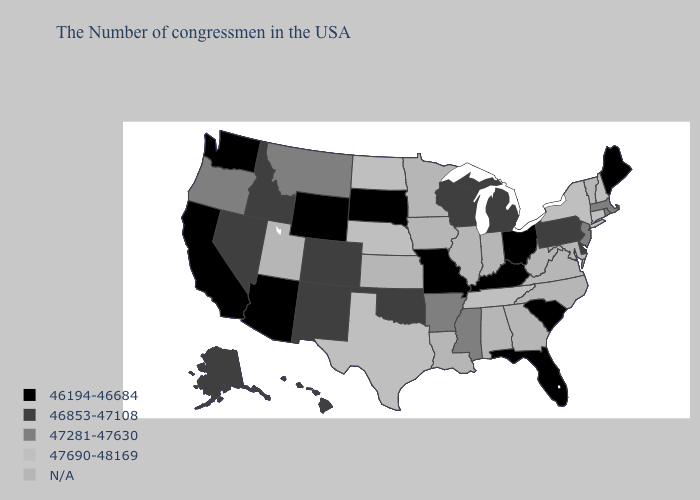What is the value of Missouri?
Short answer required. 46194-46684. Does Washington have the lowest value in the USA?
Keep it brief. Yes. Does Missouri have the lowest value in the USA?
Concise answer only. Yes. What is the value of Ohio?
Be succinct. 46194-46684. What is the lowest value in the MidWest?
Concise answer only. 46194-46684. Among the states that border California , does Arizona have the lowest value?
Be succinct. Yes. What is the value of North Dakota?
Quick response, please. 47690-48169. Name the states that have a value in the range 46853-47108?
Concise answer only. Delaware, Pennsylvania, Michigan, Wisconsin, Oklahoma, Colorado, New Mexico, Idaho, Nevada, Alaska, Hawaii. How many symbols are there in the legend?
Give a very brief answer. 5. Which states have the lowest value in the USA?
Keep it brief. Maine, South Carolina, Ohio, Florida, Kentucky, Missouri, South Dakota, Wyoming, Arizona, California, Washington. What is the value of Colorado?
Write a very short answer. 46853-47108. Among the states that border Delaware , which have the highest value?
Keep it brief. New Jersey. Name the states that have a value in the range 46853-47108?
Concise answer only. Delaware, Pennsylvania, Michigan, Wisconsin, Oklahoma, Colorado, New Mexico, Idaho, Nevada, Alaska, Hawaii. Does Oregon have the highest value in the USA?
Quick response, please. No. Name the states that have a value in the range 46194-46684?
Write a very short answer. Maine, South Carolina, Ohio, Florida, Kentucky, Missouri, South Dakota, Wyoming, Arizona, California, Washington. 